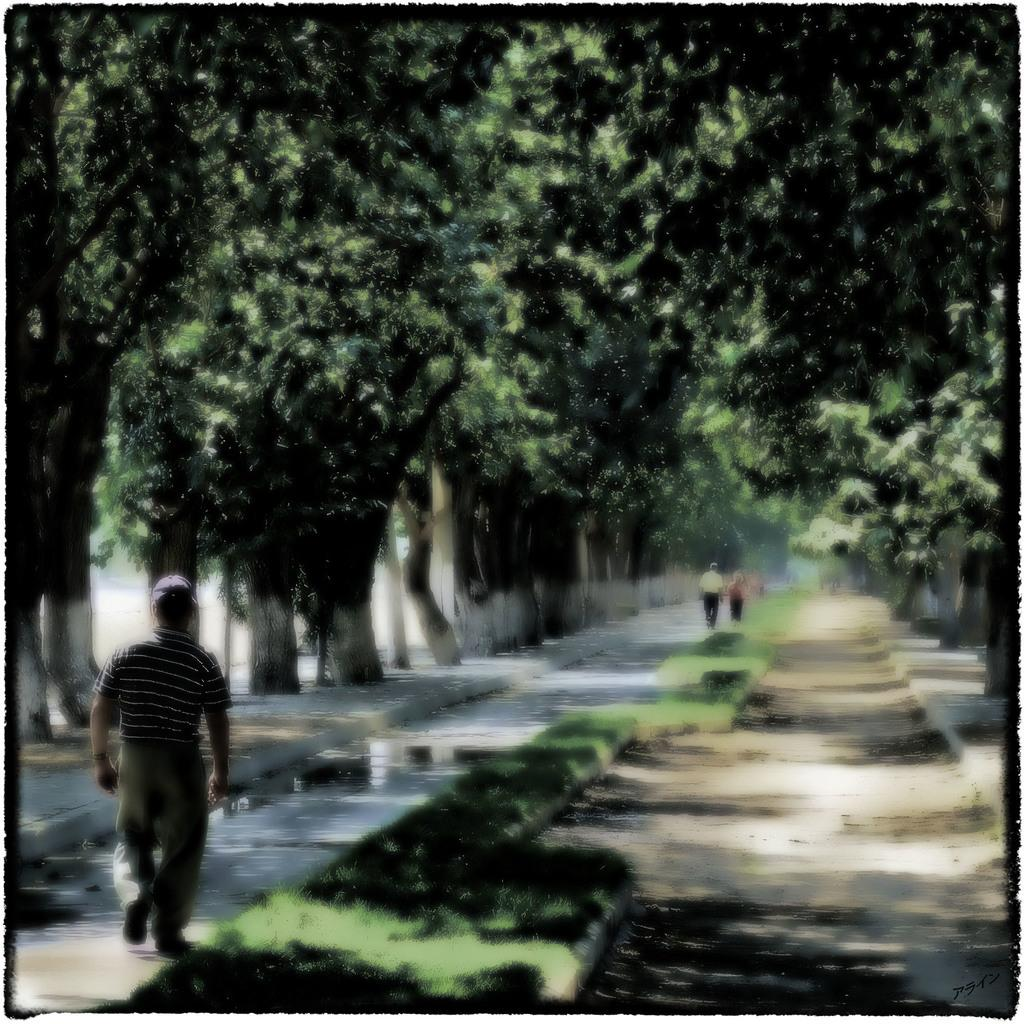Who or what can be seen in the image? There are people in the image. Where are the people located in relation to the trees? The people are between trees. What type of vegetation is visible at the bottom of the image? There is grass visible at the bottom of the image. How many legs can be seen on the people in the image? It is impossible to determine the number of legs on the people in the image, as the image does not show the people's legs. 